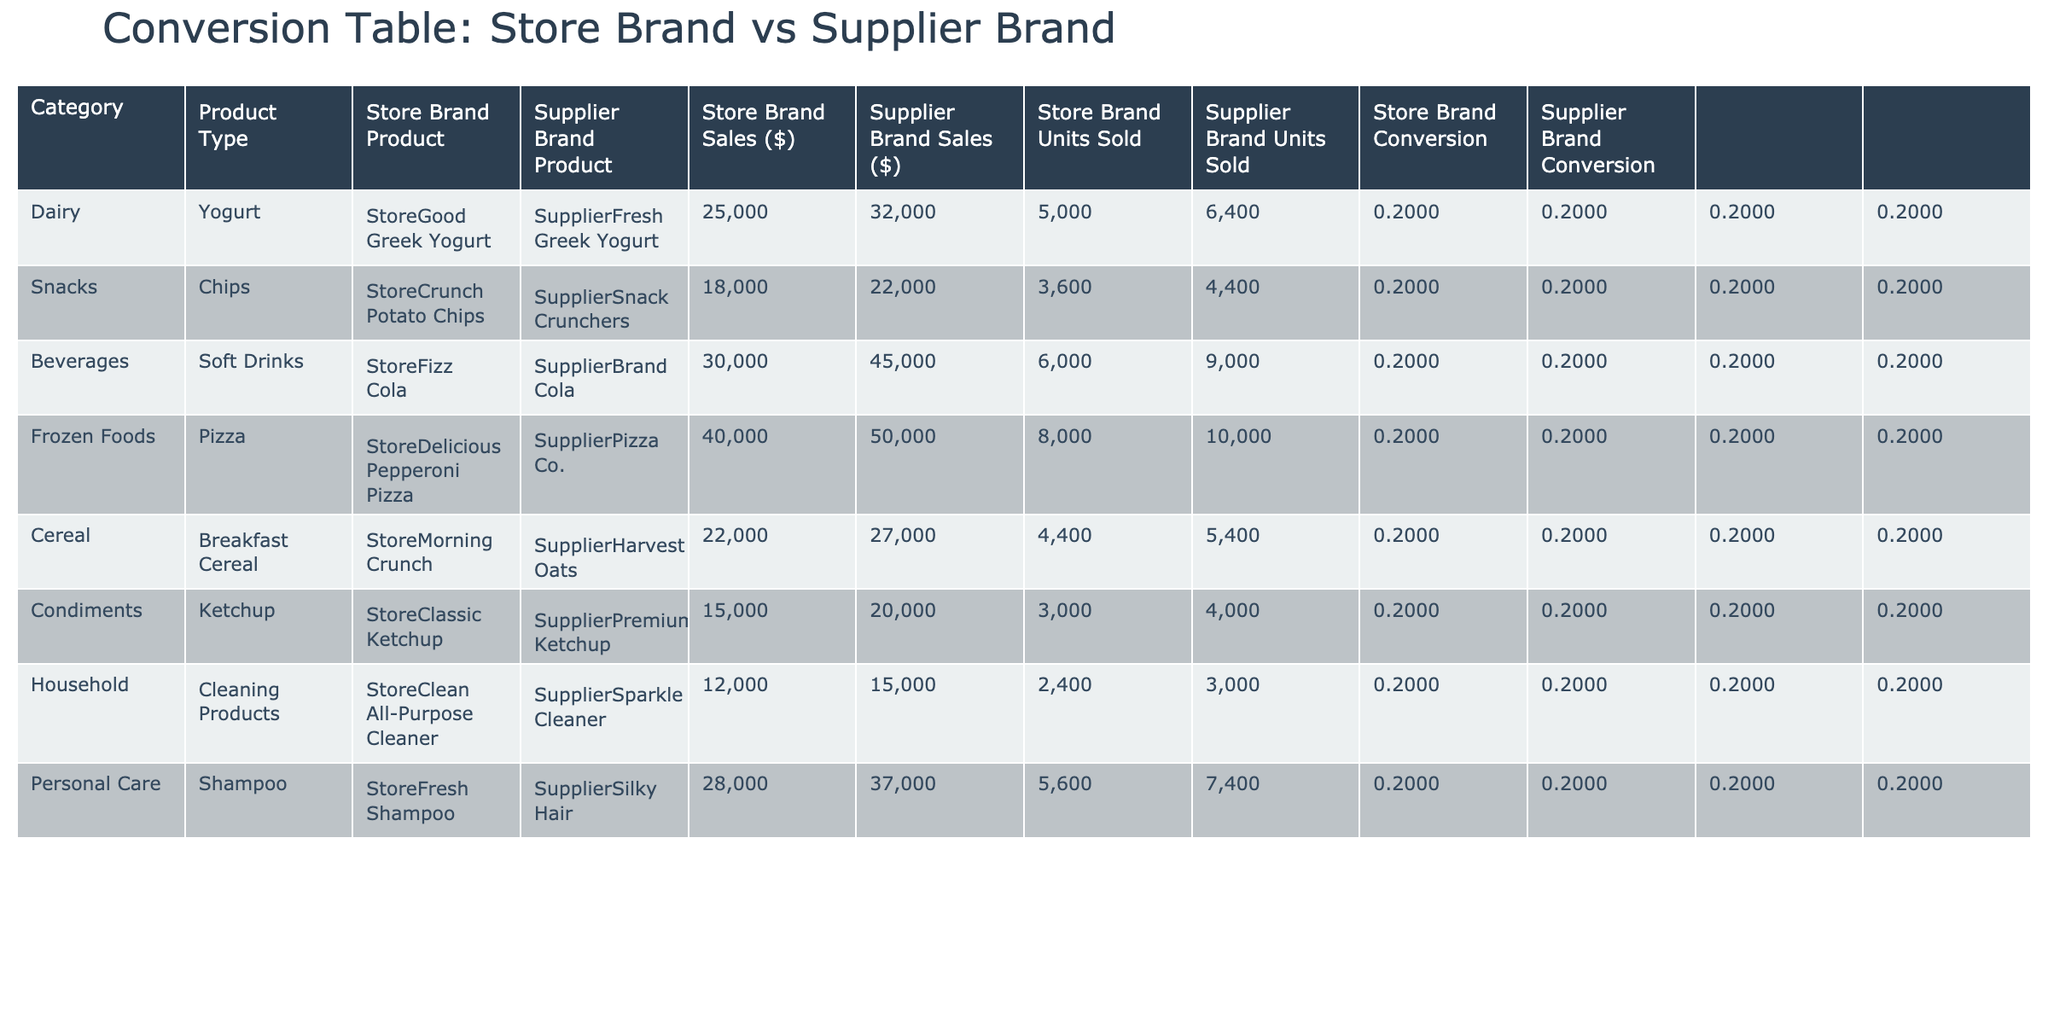What's the total sales for the Store Brand products? The total sales for Store Brand products can be calculated by summing the values in the "Store Brand Sales ($)" column: 25000 + 18000 + 30000 + 40000 + 22000 + 15000 + 12000 + 28000 = 190000.
Answer: 190000 Which Supplier Brand product has the highest sales? To find this, we look through the "Supplier Brand Sales ($)" column and identify the maximum value, which belongs to "Supplier Brand Cola" with sales of 45000.
Answer: Supplier Brand Cola Is the Store Brand product "StoreClean All-Purpose Cleaner" performing better than its Supplier counterpart? We compare the sales and units sold of both products. "StoreClean All-Purpose Cleaner" has sales of 12000 and units sold of 2400, while "Supplier Sparkle Cleaner" has sales of 15000 with 3000 units sold. Since its sales are less than the supplier's, it is not performing better.
Answer: No What is the ratio of units sold for Store Brand to Supplier Brand for the Dairy category? For the Dairy category, the Store Brand units sold are 5000, and the Supplier Brand units sold are 6400. The ratio is 5000:6400, which simplifies to 25:32.
Answer: 25:32 Which category has the highest Store Brand conversion rate? We calculate the conversion rate for each category by taking the "Store Brand Units Sold" and dividing by "Store Brand Sales ($)". Calculating gives us the conversion rates: Dairy (0.2000), Snacks (0.2000), Beverages (0.2000), Frozen Foods (0.2000), Cereal (0.2000), Condiments (0.2000), Household (0.2000), Personal Care (0.2000). All categories have the same conversion rate.
Answer: All categories have the same conversion rate What is the difference in sales between the highest and lowest performing Store Brand products? First, we identify the highest sale, which is for Frozen Foods (40000), and the lowest sale, which is for Household (12000). Their difference is calculated as 40000 - 12000 = 28000.
Answer: 28000 Is it true that all Supplier Brand products sold more than their Store Brand counterparts? We analyze each pair of Store Brand and Supplier Brand sales values. In all cases, Supplier Brand sales exceed Store Brand sales, indicating that the statement is true.
Answer: Yes What is the combined total sales for all Supplier Brand products? To find the total sales for Supplier Brand products, we sum the values in the "Supplier Brand Sales ($)" column: 32000 + 22000 + 45000 + 50000 + 27000 + 20000 + 15000 + 37000 = 258000.
Answer: 258000 